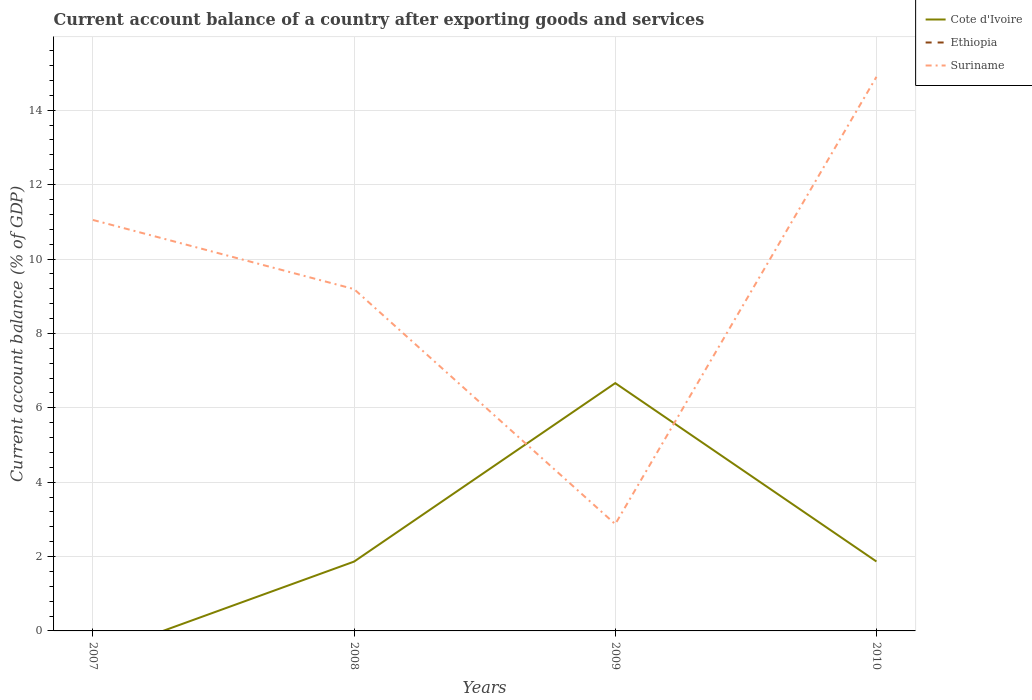How many different coloured lines are there?
Your answer should be very brief. 2. Does the line corresponding to Cote d'Ivoire intersect with the line corresponding to Ethiopia?
Ensure brevity in your answer.  No. Is the number of lines equal to the number of legend labels?
Offer a terse response. No. Across all years, what is the maximum account balance in Suriname?
Make the answer very short. 2.87. What is the total account balance in Suriname in the graph?
Offer a very short reply. 6.32. What is the difference between the highest and the second highest account balance in Suriname?
Provide a short and direct response. 12.03. How many lines are there?
Keep it short and to the point. 2. How many years are there in the graph?
Keep it short and to the point. 4. Does the graph contain grids?
Your answer should be very brief. Yes. Where does the legend appear in the graph?
Offer a terse response. Top right. What is the title of the graph?
Your answer should be very brief. Current account balance of a country after exporting goods and services. What is the label or title of the Y-axis?
Provide a succinct answer. Current account balance (% of GDP). What is the Current account balance (% of GDP) of Cote d'Ivoire in 2007?
Keep it short and to the point. 0. What is the Current account balance (% of GDP) of Suriname in 2007?
Keep it short and to the point. 11.05. What is the Current account balance (% of GDP) of Cote d'Ivoire in 2008?
Give a very brief answer. 1.86. What is the Current account balance (% of GDP) of Ethiopia in 2008?
Give a very brief answer. 0. What is the Current account balance (% of GDP) in Suriname in 2008?
Your response must be concise. 9.19. What is the Current account balance (% of GDP) of Cote d'Ivoire in 2009?
Ensure brevity in your answer.  6.66. What is the Current account balance (% of GDP) of Ethiopia in 2009?
Provide a succinct answer. 0. What is the Current account balance (% of GDP) of Suriname in 2009?
Keep it short and to the point. 2.87. What is the Current account balance (% of GDP) in Cote d'Ivoire in 2010?
Your answer should be compact. 1.87. What is the Current account balance (% of GDP) of Suriname in 2010?
Your answer should be compact. 14.9. Across all years, what is the maximum Current account balance (% of GDP) in Cote d'Ivoire?
Offer a very short reply. 6.66. Across all years, what is the maximum Current account balance (% of GDP) in Suriname?
Ensure brevity in your answer.  14.9. Across all years, what is the minimum Current account balance (% of GDP) in Suriname?
Keep it short and to the point. 2.87. What is the total Current account balance (% of GDP) in Cote d'Ivoire in the graph?
Your answer should be compact. 10.39. What is the total Current account balance (% of GDP) in Ethiopia in the graph?
Your answer should be very brief. 0. What is the total Current account balance (% of GDP) of Suriname in the graph?
Offer a very short reply. 38.01. What is the difference between the Current account balance (% of GDP) in Suriname in 2007 and that in 2008?
Ensure brevity in your answer.  1.86. What is the difference between the Current account balance (% of GDP) in Suriname in 2007 and that in 2009?
Offer a very short reply. 8.18. What is the difference between the Current account balance (% of GDP) in Suriname in 2007 and that in 2010?
Keep it short and to the point. -3.85. What is the difference between the Current account balance (% of GDP) of Cote d'Ivoire in 2008 and that in 2009?
Provide a short and direct response. -4.8. What is the difference between the Current account balance (% of GDP) of Suriname in 2008 and that in 2009?
Give a very brief answer. 6.32. What is the difference between the Current account balance (% of GDP) of Cote d'Ivoire in 2008 and that in 2010?
Provide a short and direct response. -0. What is the difference between the Current account balance (% of GDP) in Suriname in 2008 and that in 2010?
Keep it short and to the point. -5.71. What is the difference between the Current account balance (% of GDP) of Cote d'Ivoire in 2009 and that in 2010?
Provide a succinct answer. 4.8. What is the difference between the Current account balance (% of GDP) in Suriname in 2009 and that in 2010?
Give a very brief answer. -12.03. What is the difference between the Current account balance (% of GDP) in Cote d'Ivoire in 2008 and the Current account balance (% of GDP) in Suriname in 2009?
Make the answer very short. -1.01. What is the difference between the Current account balance (% of GDP) of Cote d'Ivoire in 2008 and the Current account balance (% of GDP) of Suriname in 2010?
Your answer should be very brief. -13.03. What is the difference between the Current account balance (% of GDP) of Cote d'Ivoire in 2009 and the Current account balance (% of GDP) of Suriname in 2010?
Offer a terse response. -8.23. What is the average Current account balance (% of GDP) of Cote d'Ivoire per year?
Ensure brevity in your answer.  2.6. What is the average Current account balance (% of GDP) of Ethiopia per year?
Offer a very short reply. 0. What is the average Current account balance (% of GDP) in Suriname per year?
Offer a terse response. 9.5. In the year 2008, what is the difference between the Current account balance (% of GDP) of Cote d'Ivoire and Current account balance (% of GDP) of Suriname?
Provide a short and direct response. -7.33. In the year 2009, what is the difference between the Current account balance (% of GDP) in Cote d'Ivoire and Current account balance (% of GDP) in Suriname?
Your answer should be compact. 3.79. In the year 2010, what is the difference between the Current account balance (% of GDP) in Cote d'Ivoire and Current account balance (% of GDP) in Suriname?
Offer a terse response. -13.03. What is the ratio of the Current account balance (% of GDP) of Suriname in 2007 to that in 2008?
Provide a succinct answer. 1.2. What is the ratio of the Current account balance (% of GDP) in Suriname in 2007 to that in 2009?
Make the answer very short. 3.85. What is the ratio of the Current account balance (% of GDP) in Suriname in 2007 to that in 2010?
Your response must be concise. 0.74. What is the ratio of the Current account balance (% of GDP) in Cote d'Ivoire in 2008 to that in 2009?
Provide a succinct answer. 0.28. What is the ratio of the Current account balance (% of GDP) of Suriname in 2008 to that in 2009?
Provide a succinct answer. 3.2. What is the ratio of the Current account balance (% of GDP) of Cote d'Ivoire in 2008 to that in 2010?
Provide a succinct answer. 1. What is the ratio of the Current account balance (% of GDP) in Suriname in 2008 to that in 2010?
Ensure brevity in your answer.  0.62. What is the ratio of the Current account balance (% of GDP) in Cote d'Ivoire in 2009 to that in 2010?
Your answer should be very brief. 3.57. What is the ratio of the Current account balance (% of GDP) of Suriname in 2009 to that in 2010?
Ensure brevity in your answer.  0.19. What is the difference between the highest and the second highest Current account balance (% of GDP) in Cote d'Ivoire?
Offer a terse response. 4.8. What is the difference between the highest and the second highest Current account balance (% of GDP) in Suriname?
Offer a very short reply. 3.85. What is the difference between the highest and the lowest Current account balance (% of GDP) of Cote d'Ivoire?
Offer a terse response. 6.66. What is the difference between the highest and the lowest Current account balance (% of GDP) in Suriname?
Offer a very short reply. 12.03. 